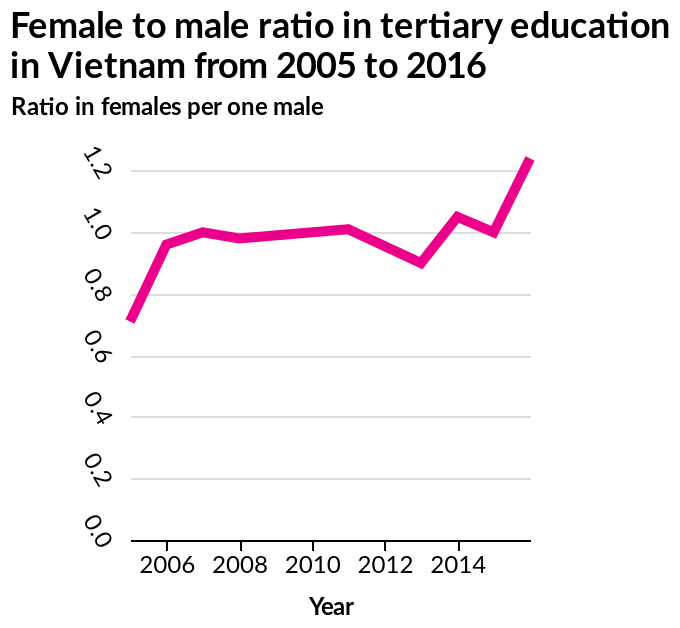<image>
By approximately how much did the ratio of females to males in tertiary education increase from 2005 to 2016?  The ratio of females to males in tertiary education increased by approximately 70% from 2005 to 2016. 